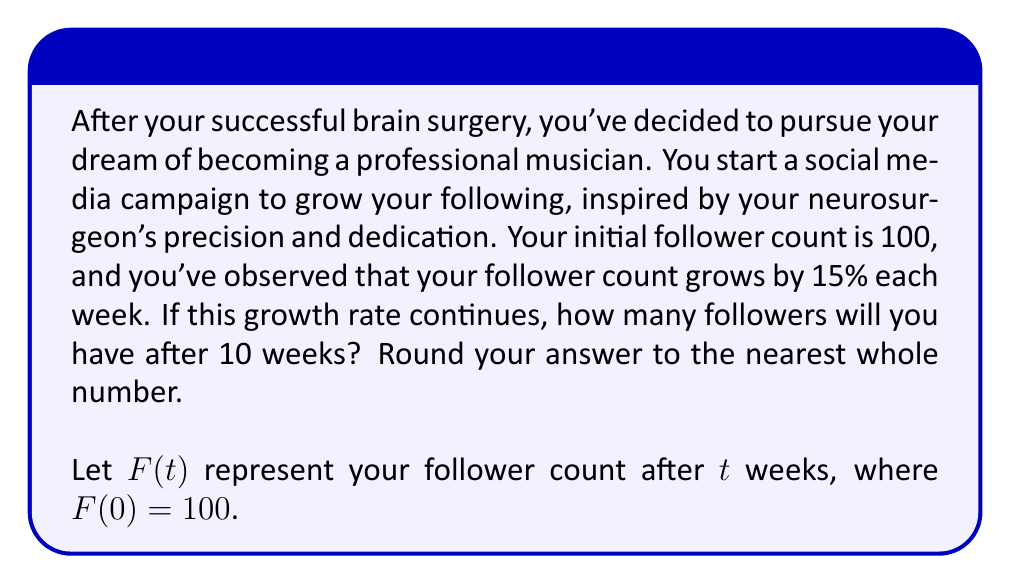Show me your answer to this math problem. To solve this problem, we'll use an exponential growth model:

1) The general form of exponential growth is:
   $F(t) = F(0) \cdot (1 + r)^t$
   where $F(0)$ is the initial value, $r$ is the growth rate, and $t$ is the time.

2) In this case:
   $F(0) = 100$ (initial followers)
   $r = 0.15$ (15% growth rate)
   $t = 10$ (weeks)

3) Plugging these values into our equation:
   $F(10) = 100 \cdot (1 + 0.15)^{10}$

4) Simplify:
   $F(10) = 100 \cdot (1.15)^{10}$

5) Calculate:
   $F(10) = 100 \cdot 4.0456$
   $F(10) = 404.56$

6) Rounding to the nearest whole number:
   $F(10) \approx 405$

Therefore, after 10 weeks, you will have approximately 405 followers.
Answer: 405 followers 